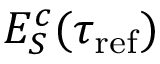Convert formula to latex. <formula><loc_0><loc_0><loc_500><loc_500>E _ { S } ^ { c } ( \tau _ { r e f } )</formula> 